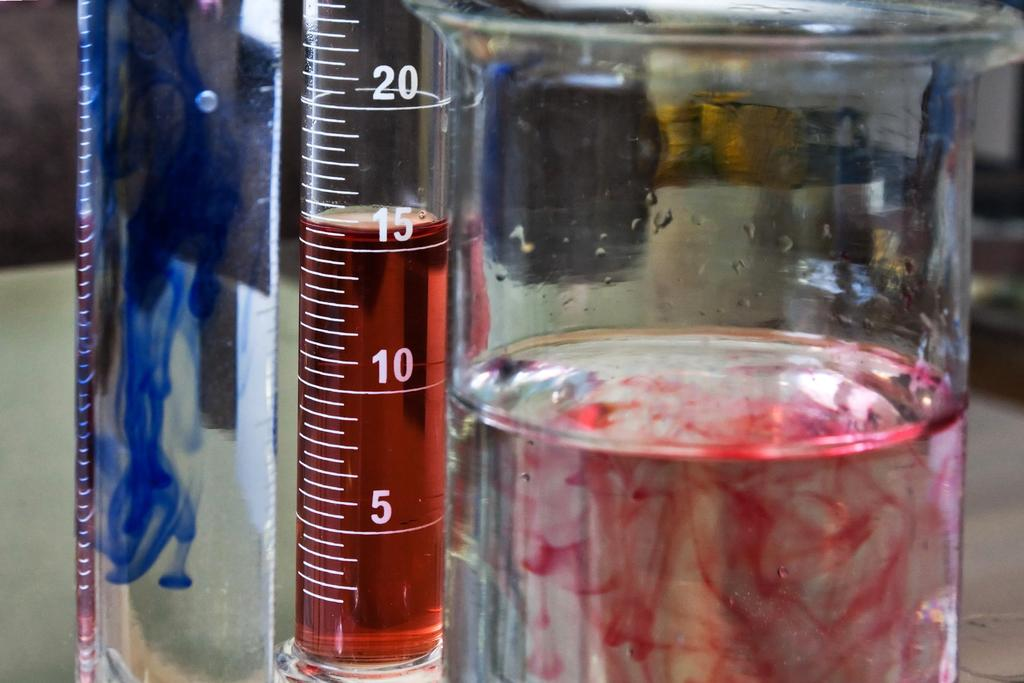<image>
Give a short and clear explanation of the subsequent image. Measuring cup that measures from one to twenty. 